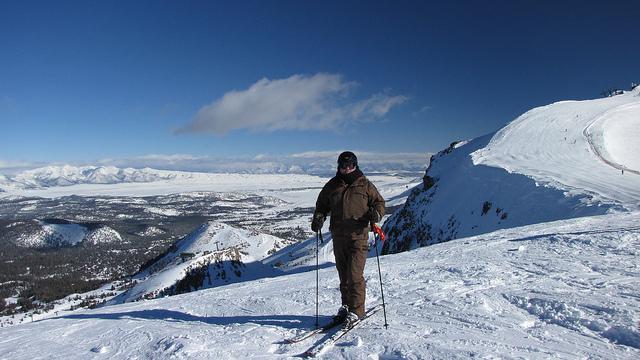Is the person in the photo facing downhill?
Quick response, please. No. Is the man standing on the highest peak in the region?
Quick response, please. No. What is this person on?
Answer briefly. Skis. 